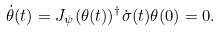<formula> <loc_0><loc_0><loc_500><loc_500>\dot { \theta } ( t ) = J _ { \psi } ( \theta ( t ) ) ^ { \dag } \dot { \sigma } ( t ) \theta ( 0 ) = 0 .</formula> 